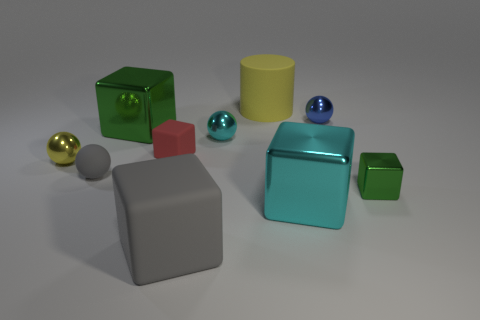Is there a big green object?
Provide a succinct answer. Yes. The tiny green object that is made of the same material as the large cyan thing is what shape?
Keep it short and to the point. Cube. There is a large cube behind the tiny metallic block; what is its material?
Offer a terse response. Metal. Does the block that is on the left side of the small red rubber cube have the same color as the tiny metallic block?
Offer a terse response. Yes. What is the size of the green metal object to the right of the green cube left of the tiny red thing?
Your answer should be very brief. Small. Is the number of big yellow things in front of the large green shiny cube greater than the number of cylinders?
Keep it short and to the point. No. There is a yellow thing in front of the red matte thing; is it the same size as the small cyan metal ball?
Offer a terse response. Yes. The small metallic thing that is to the left of the tiny green cube and right of the yellow matte object is what color?
Offer a terse response. Blue. What is the shape of the gray thing that is the same size as the cylinder?
Provide a short and direct response. Cube. Is there a tiny metal object that has the same color as the tiny metal cube?
Provide a short and direct response. No. 